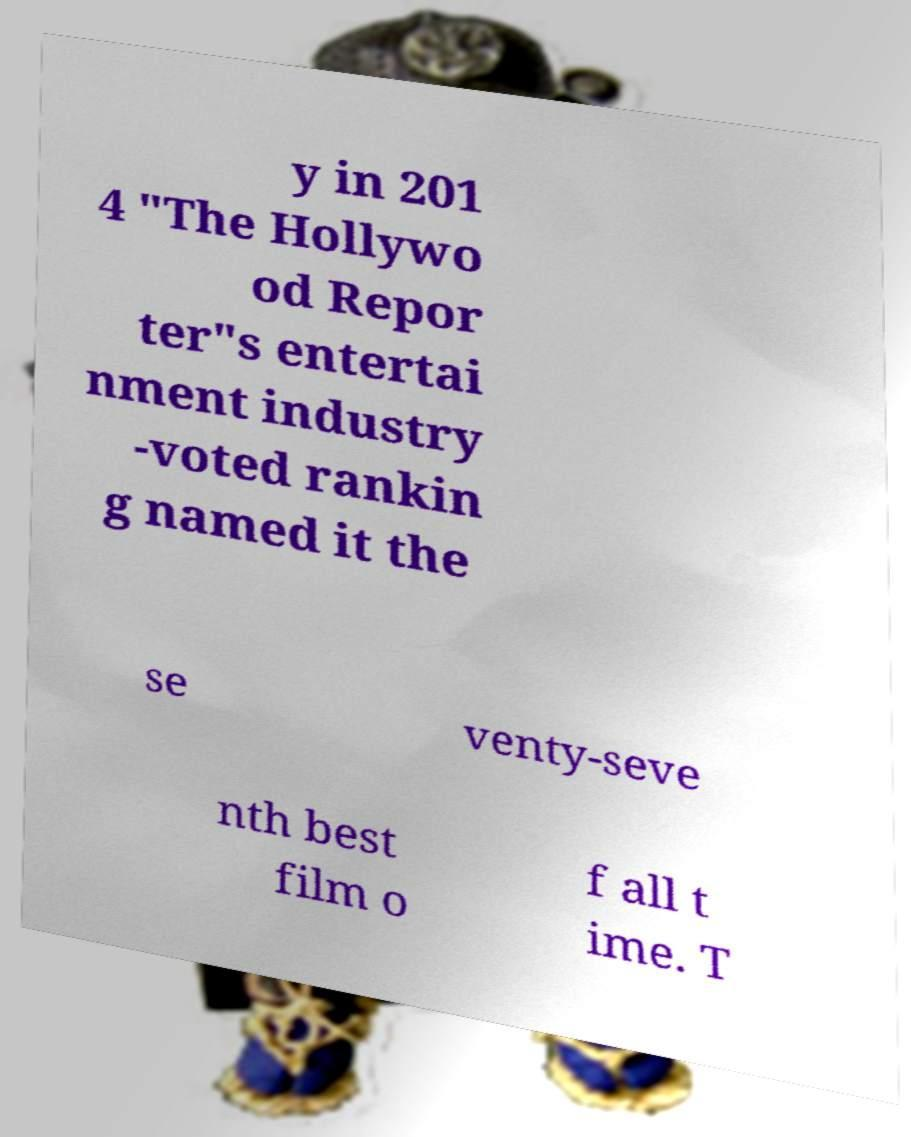Could you extract and type out the text from this image? y in 201 4 "The Hollywo od Repor ter"s entertai nment industry -voted rankin g named it the se venty-seve nth best film o f all t ime. T 